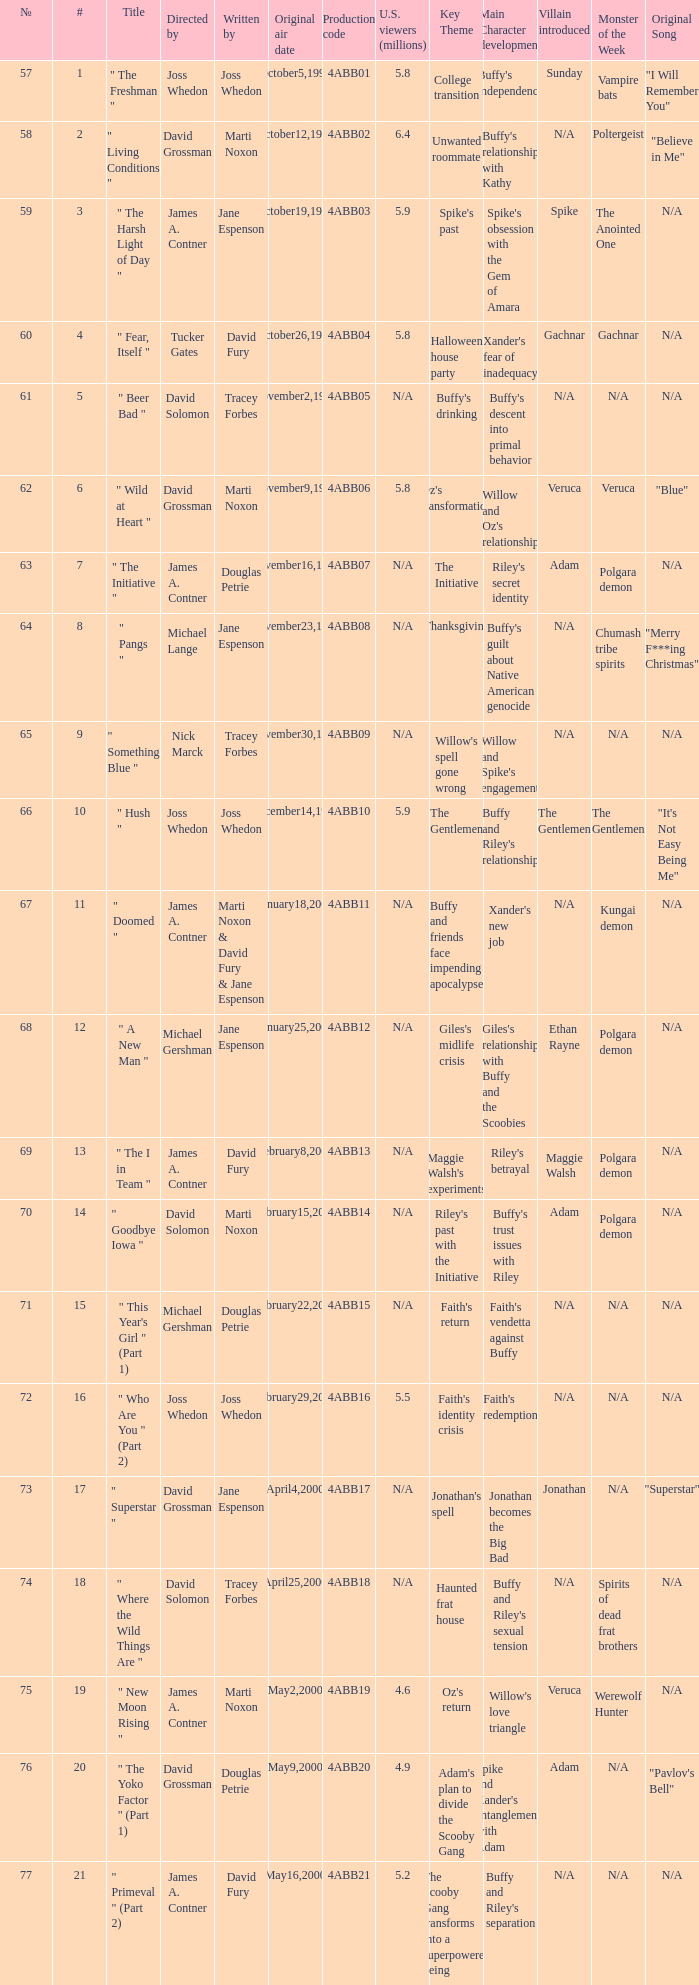What is the title of episode No. 65? " Something Blue ". 